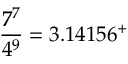<formula> <loc_0><loc_0><loc_500><loc_500>{ \frac { 7 ^ { 7 } } { 4 ^ { 9 } } } = 3 . 1 4 1 5 6 ^ { + }</formula> 